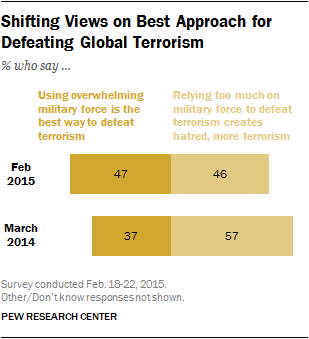Highlight a few significant elements in this photo. In 2014 and 2015, there was a small but significant difference in the percentage of individuals who supported using military force to defeat terrorism. Specifically, the percentage who supported this approach in 2015 was slightly higher than it was in 2014, with a difference of 0.1%. This suggests that public opinion on this issue may have shifted slightly over the course of two years, with more individuals becoming supportive of using military force to combat terrorism. The comparison of values between March 2014 and February 2015 reveals that they are not equal. 